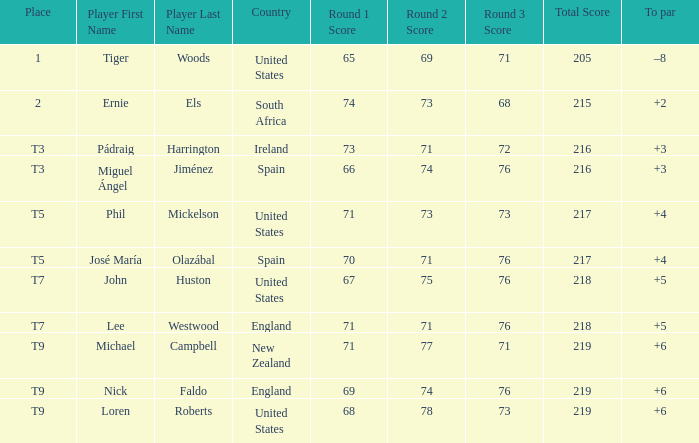What is Score, when Country is "United States", and when To Par is "+4"? 71-73-73=217. 